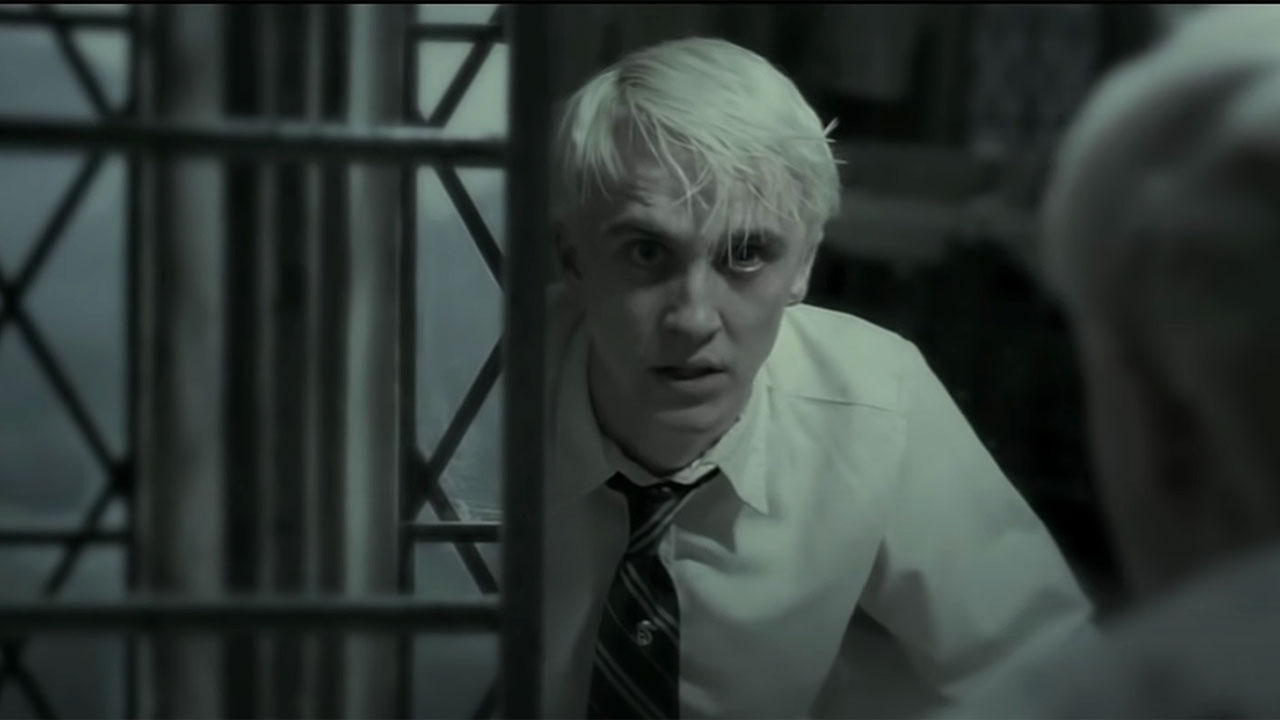If this scene was part of a modern high school drama, what would be the context? In a modern high school drama setting, this image could represent a pivotal moment for a student named Drake. Dressed in standard school attire, Drake is standing behind the bars of a fence that separates him from the school's courtyard. His troubled expression reflects the peak of a personal crisis. Perhaps he has just uncovered a betrayal by his closest friends, or learned a devastating secret about his family. The grayscale filter emphasizes the gravity of the situation, highlighting his feelings of isolation and entrapment. This moment marks a turning point in Drake's story, where he contemplates the actions he must take to confront and navigate his newfound challenges, leading to significant character development and dramatic storyline twists. 